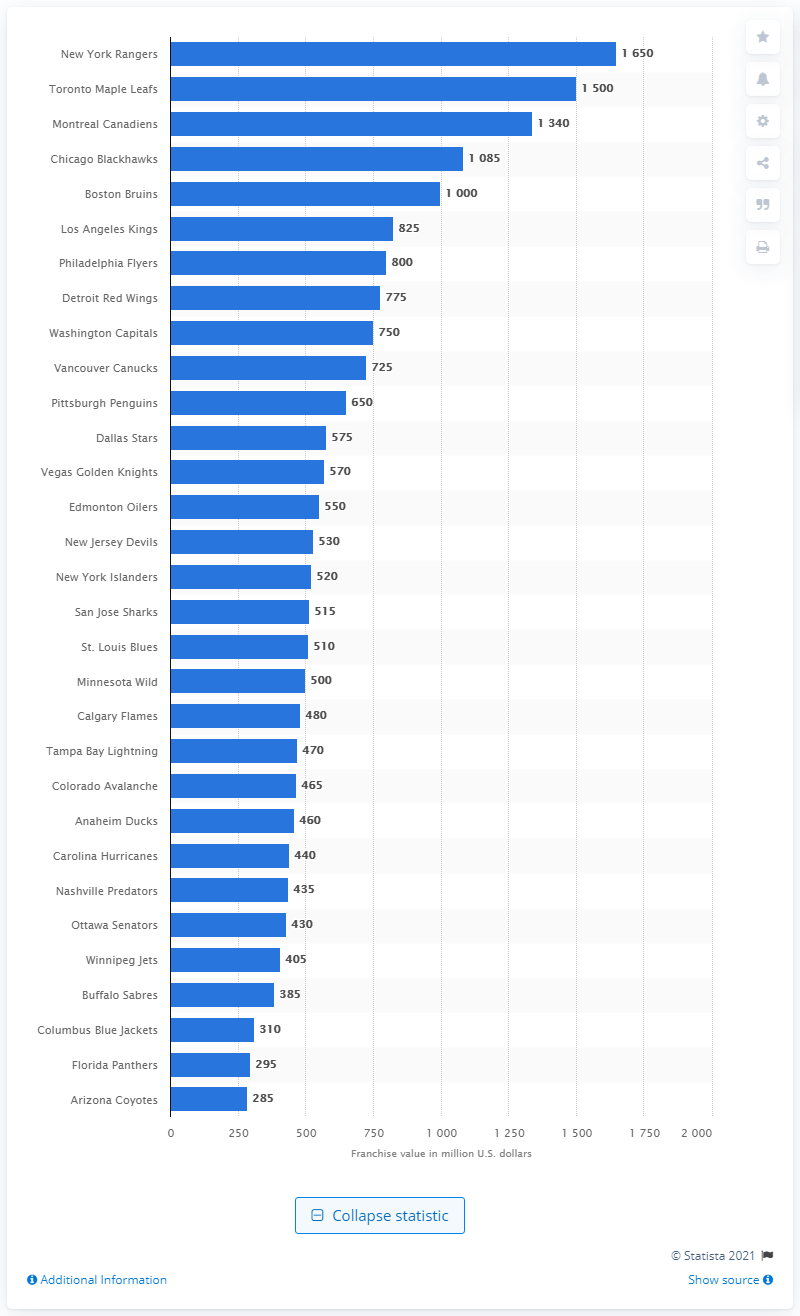Point out several critical features in this image. The estimated worth of the Nashville Predators franchise in 2020 was 435 million dollars. 